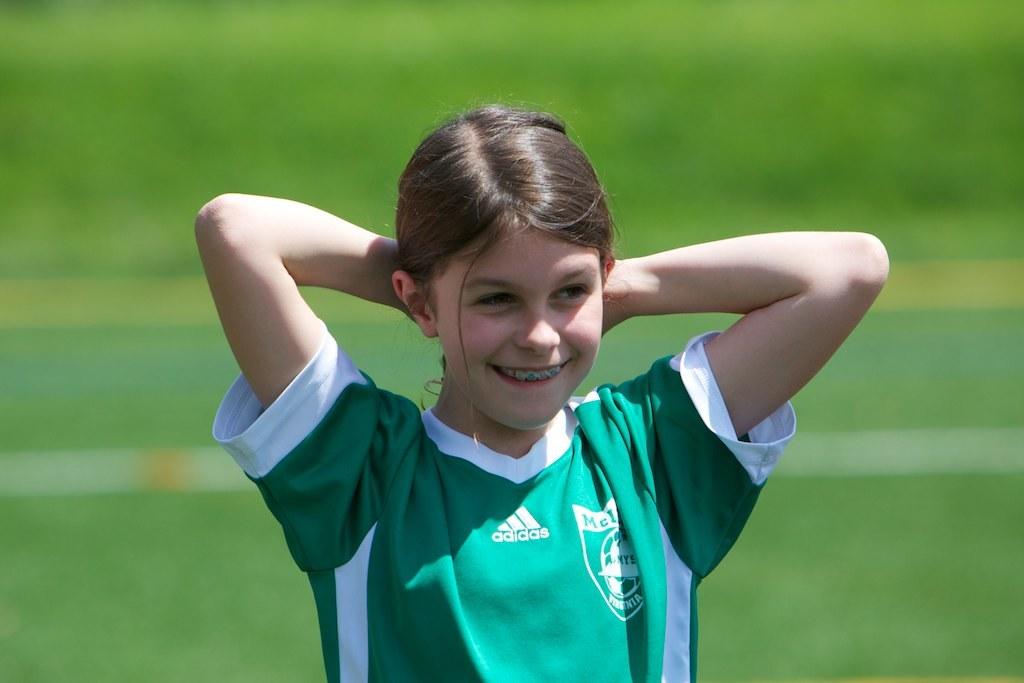What name brand is the shirt?
Your answer should be compact. Adidas. 